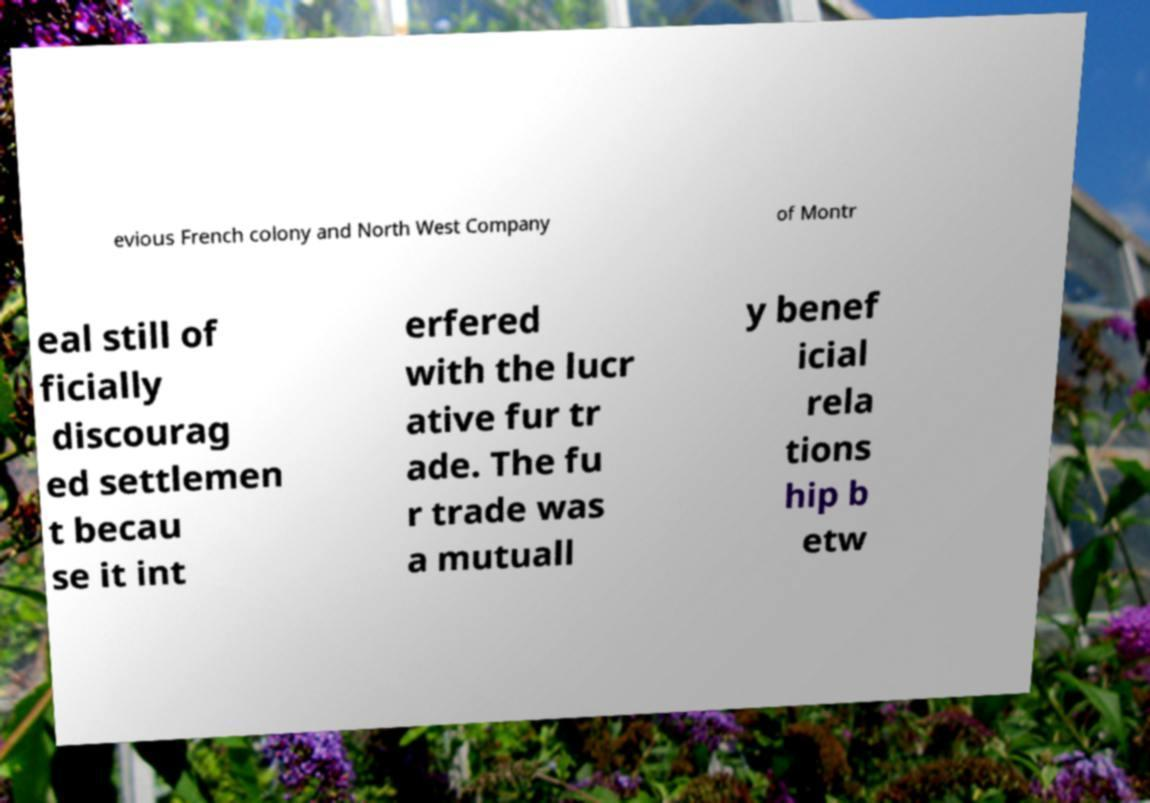Can you read and provide the text displayed in the image?This photo seems to have some interesting text. Can you extract and type it out for me? evious French colony and North West Company of Montr eal still of ficially discourag ed settlemen t becau se it int erfered with the lucr ative fur tr ade. The fu r trade was a mutuall y benef icial rela tions hip b etw 